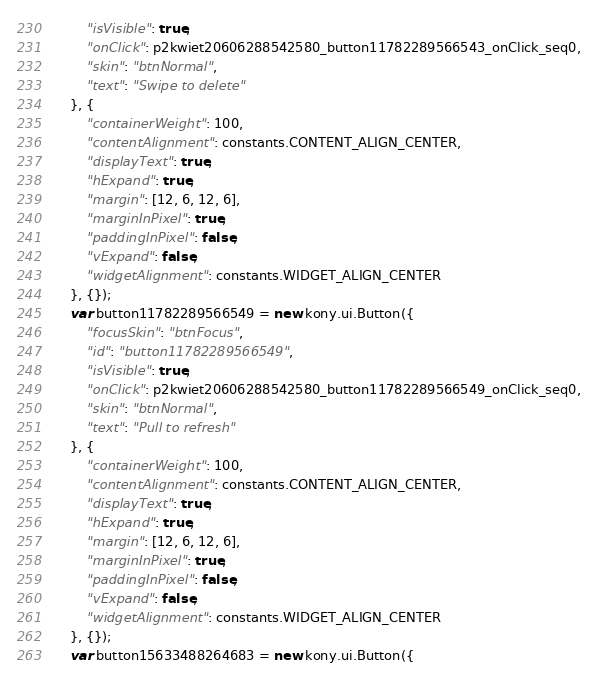<code> <loc_0><loc_0><loc_500><loc_500><_JavaScript_>        "isVisible": true,
        "onClick": p2kwiet20606288542580_button11782289566543_onClick_seq0,
        "skin": "btnNormal",
        "text": "Swipe to delete"
    }, {
        "containerWeight": 100,
        "contentAlignment": constants.CONTENT_ALIGN_CENTER,
        "displayText": true,
        "hExpand": true,
        "margin": [12, 6, 12, 6],
        "marginInPixel": true,
        "paddingInPixel": false,
        "vExpand": false,
        "widgetAlignment": constants.WIDGET_ALIGN_CENTER
    }, {});
    var button11782289566549 = new kony.ui.Button({
        "focusSkin": "btnFocus",
        "id": "button11782289566549",
        "isVisible": true,
        "onClick": p2kwiet20606288542580_button11782289566549_onClick_seq0,
        "skin": "btnNormal",
        "text": "Pull to refresh"
    }, {
        "containerWeight": 100,
        "contentAlignment": constants.CONTENT_ALIGN_CENTER,
        "displayText": true,
        "hExpand": true,
        "margin": [12, 6, 12, 6],
        "marginInPixel": true,
        "paddingInPixel": false,
        "vExpand": false,
        "widgetAlignment": constants.WIDGET_ALIGN_CENTER
    }, {});
    var button15633488264683 = new kony.ui.Button({</code> 